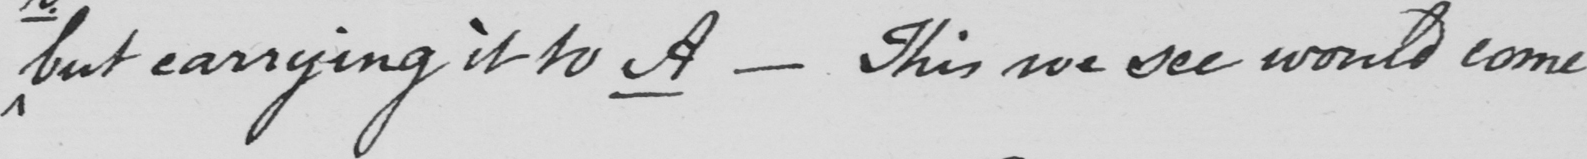Can you tell me what this handwritten text says? but carrying it to A _  This we see would come 